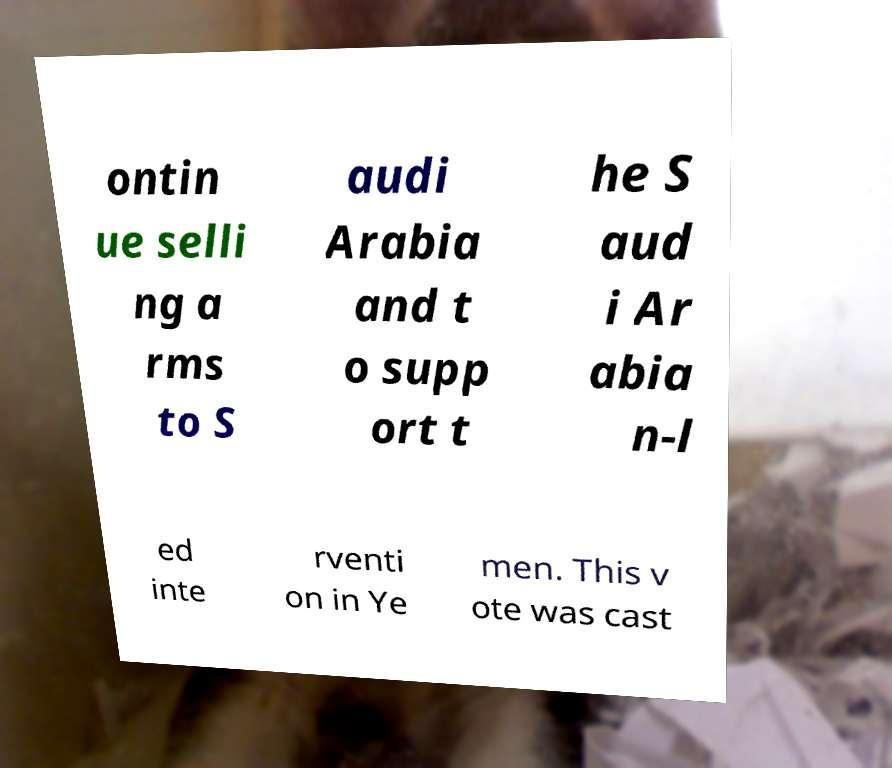I need the written content from this picture converted into text. Can you do that? ontin ue selli ng a rms to S audi Arabia and t o supp ort t he S aud i Ar abia n-l ed inte rventi on in Ye men. This v ote was cast 